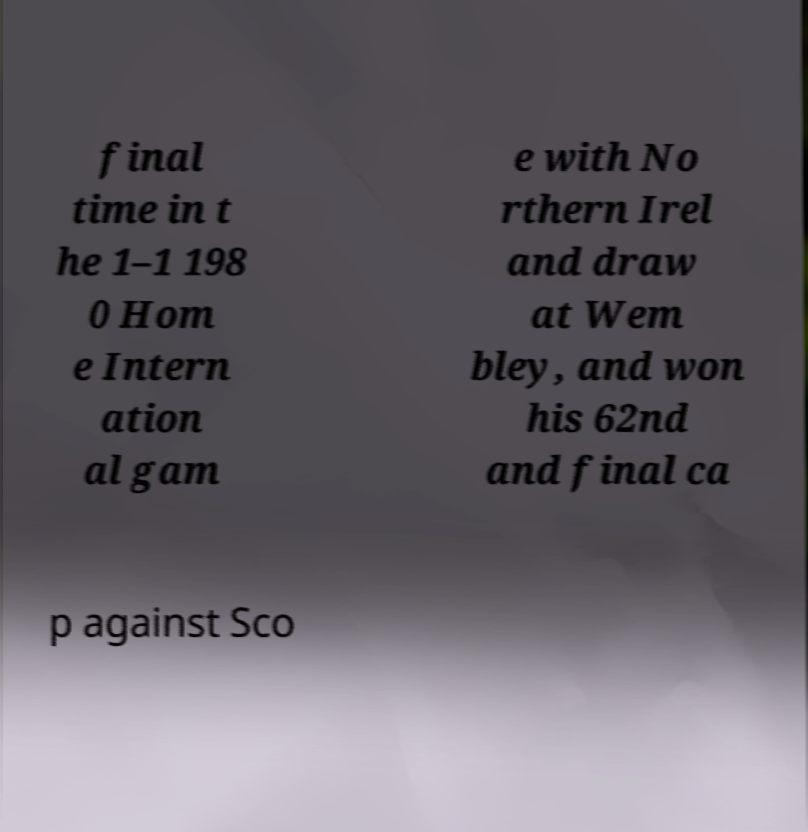There's text embedded in this image that I need extracted. Can you transcribe it verbatim? final time in t he 1–1 198 0 Hom e Intern ation al gam e with No rthern Irel and draw at Wem bley, and won his 62nd and final ca p against Sco 